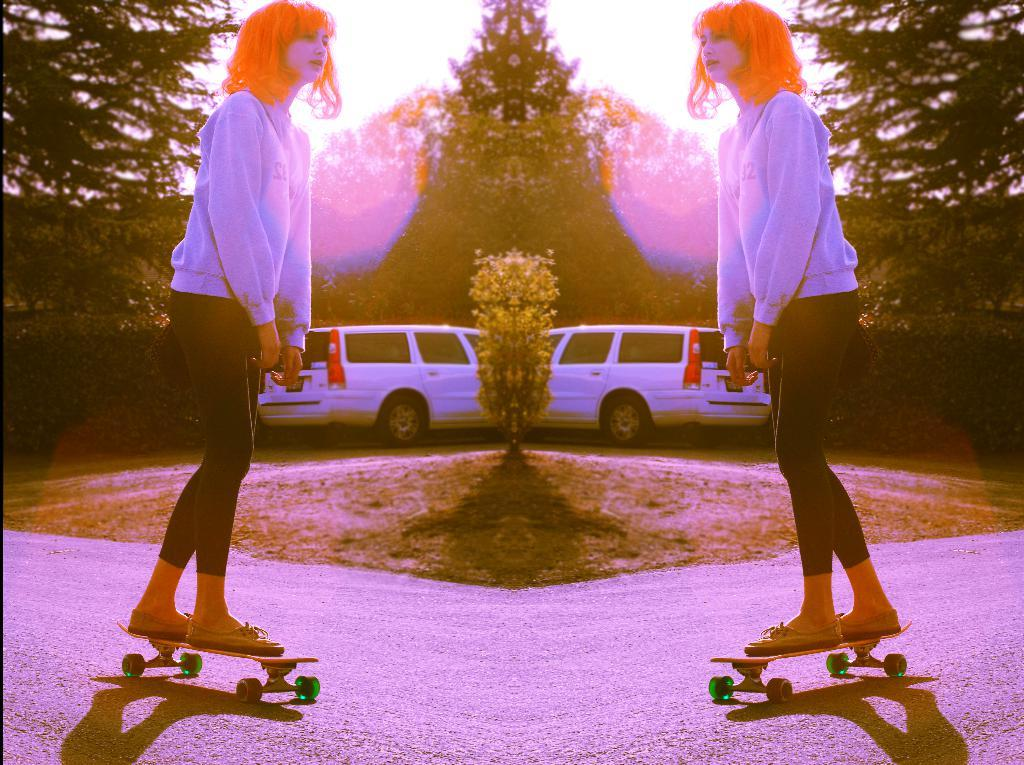Who is the main subject in the image? There is a woman in the image. What is the woman doing in the image? The woman is skating on the road. Are there any vehicles in the image? Yes, there is a car in the image. What type of natural elements can be seen in the image? There are trees in the image. What type of stick is the woman using to guide the truck in the image? There is no truck or stick present in the image. The woman is skating on the road, and there are no trucks or sticks mentioned in the facts provided. 